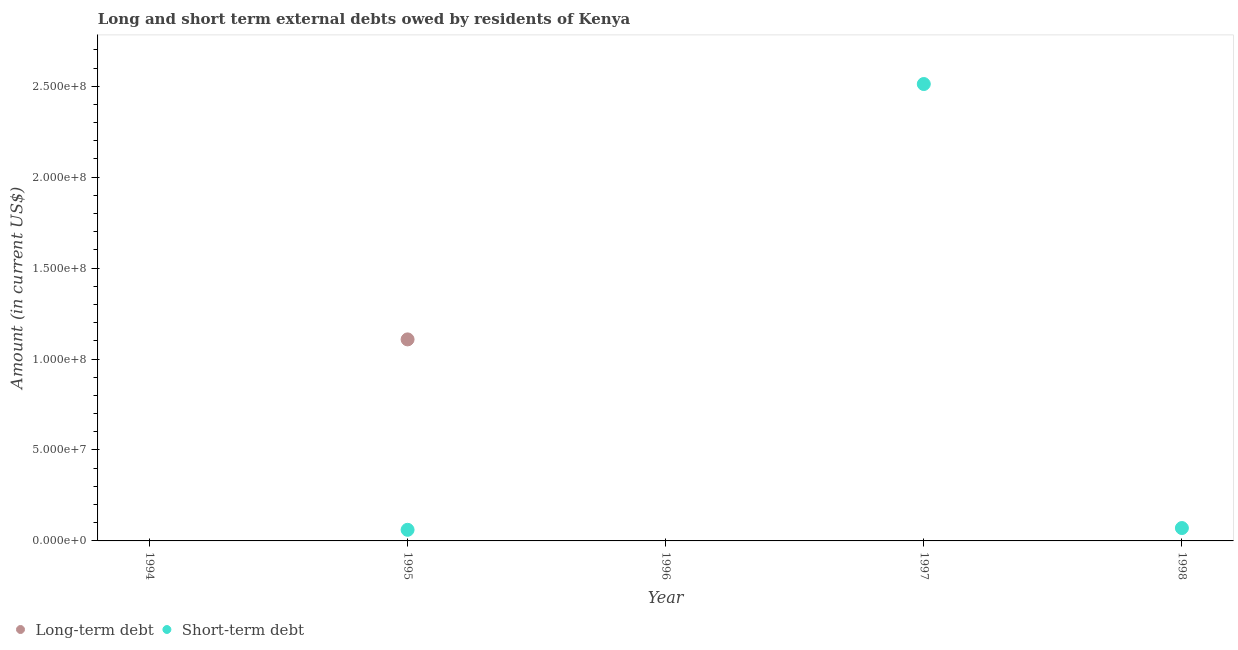Across all years, what is the maximum long-term debts owed by residents?
Make the answer very short. 1.11e+08. In which year was the long-term debts owed by residents maximum?
Provide a short and direct response. 1995. What is the total long-term debts owed by residents in the graph?
Keep it short and to the point. 1.11e+08. What is the difference between the short-term debts owed by residents in 1995 and that in 1998?
Provide a succinct answer. -9.70e+05. What is the difference between the short-term debts owed by residents in 1997 and the long-term debts owed by residents in 1998?
Make the answer very short. 2.51e+08. What is the average short-term debts owed by residents per year?
Provide a succinct answer. 5.29e+07. In the year 1995, what is the difference between the short-term debts owed by residents and long-term debts owed by residents?
Your answer should be compact. -1.05e+08. What is the ratio of the short-term debts owed by residents in 1995 to that in 1997?
Your answer should be very brief. 0.02. Is the short-term debts owed by residents in 1995 less than that in 1998?
Your answer should be very brief. Yes. What is the difference between the highest and the second highest short-term debts owed by residents?
Make the answer very short. 2.44e+08. What is the difference between the highest and the lowest long-term debts owed by residents?
Provide a short and direct response. 1.11e+08. In how many years, is the short-term debts owed by residents greater than the average short-term debts owed by residents taken over all years?
Your answer should be very brief. 1. Does the short-term debts owed by residents monotonically increase over the years?
Offer a terse response. No. Is the short-term debts owed by residents strictly less than the long-term debts owed by residents over the years?
Offer a terse response. No. What is the difference between two consecutive major ticks on the Y-axis?
Provide a short and direct response. 5.00e+07. How many legend labels are there?
Provide a succinct answer. 2. How are the legend labels stacked?
Offer a very short reply. Horizontal. What is the title of the graph?
Ensure brevity in your answer.  Long and short term external debts owed by residents of Kenya. What is the label or title of the X-axis?
Offer a terse response. Year. What is the Amount (in current US$) in Long-term debt in 1995?
Ensure brevity in your answer.  1.11e+08. What is the Amount (in current US$) of Short-term debt in 1995?
Your answer should be very brief. 6.11e+06. What is the Amount (in current US$) of Long-term debt in 1997?
Your answer should be compact. 0. What is the Amount (in current US$) in Short-term debt in 1997?
Make the answer very short. 2.51e+08. What is the Amount (in current US$) in Long-term debt in 1998?
Offer a terse response. 0. What is the Amount (in current US$) in Short-term debt in 1998?
Keep it short and to the point. 7.08e+06. Across all years, what is the maximum Amount (in current US$) of Long-term debt?
Offer a terse response. 1.11e+08. Across all years, what is the maximum Amount (in current US$) of Short-term debt?
Your response must be concise. 2.51e+08. Across all years, what is the minimum Amount (in current US$) of Long-term debt?
Make the answer very short. 0. Across all years, what is the minimum Amount (in current US$) in Short-term debt?
Provide a succinct answer. 0. What is the total Amount (in current US$) in Long-term debt in the graph?
Your answer should be very brief. 1.11e+08. What is the total Amount (in current US$) of Short-term debt in the graph?
Provide a succinct answer. 2.64e+08. What is the difference between the Amount (in current US$) of Short-term debt in 1995 and that in 1997?
Provide a succinct answer. -2.45e+08. What is the difference between the Amount (in current US$) of Short-term debt in 1995 and that in 1998?
Keep it short and to the point. -9.70e+05. What is the difference between the Amount (in current US$) of Short-term debt in 1997 and that in 1998?
Provide a short and direct response. 2.44e+08. What is the difference between the Amount (in current US$) of Long-term debt in 1995 and the Amount (in current US$) of Short-term debt in 1997?
Make the answer very short. -1.40e+08. What is the difference between the Amount (in current US$) of Long-term debt in 1995 and the Amount (in current US$) of Short-term debt in 1998?
Your response must be concise. 1.04e+08. What is the average Amount (in current US$) in Long-term debt per year?
Offer a very short reply. 2.22e+07. What is the average Amount (in current US$) in Short-term debt per year?
Make the answer very short. 5.29e+07. In the year 1995, what is the difference between the Amount (in current US$) of Long-term debt and Amount (in current US$) of Short-term debt?
Your answer should be compact. 1.05e+08. What is the ratio of the Amount (in current US$) in Short-term debt in 1995 to that in 1997?
Ensure brevity in your answer.  0.02. What is the ratio of the Amount (in current US$) in Short-term debt in 1995 to that in 1998?
Provide a short and direct response. 0.86. What is the ratio of the Amount (in current US$) of Short-term debt in 1997 to that in 1998?
Your response must be concise. 35.48. What is the difference between the highest and the second highest Amount (in current US$) of Short-term debt?
Ensure brevity in your answer.  2.44e+08. What is the difference between the highest and the lowest Amount (in current US$) of Long-term debt?
Give a very brief answer. 1.11e+08. What is the difference between the highest and the lowest Amount (in current US$) of Short-term debt?
Your answer should be compact. 2.51e+08. 